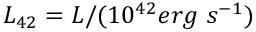<formula> <loc_0><loc_0><loc_500><loc_500>L _ { 4 2 } = L / ( 1 0 ^ { 4 2 } e r g \, s ^ { - 1 } )</formula> 